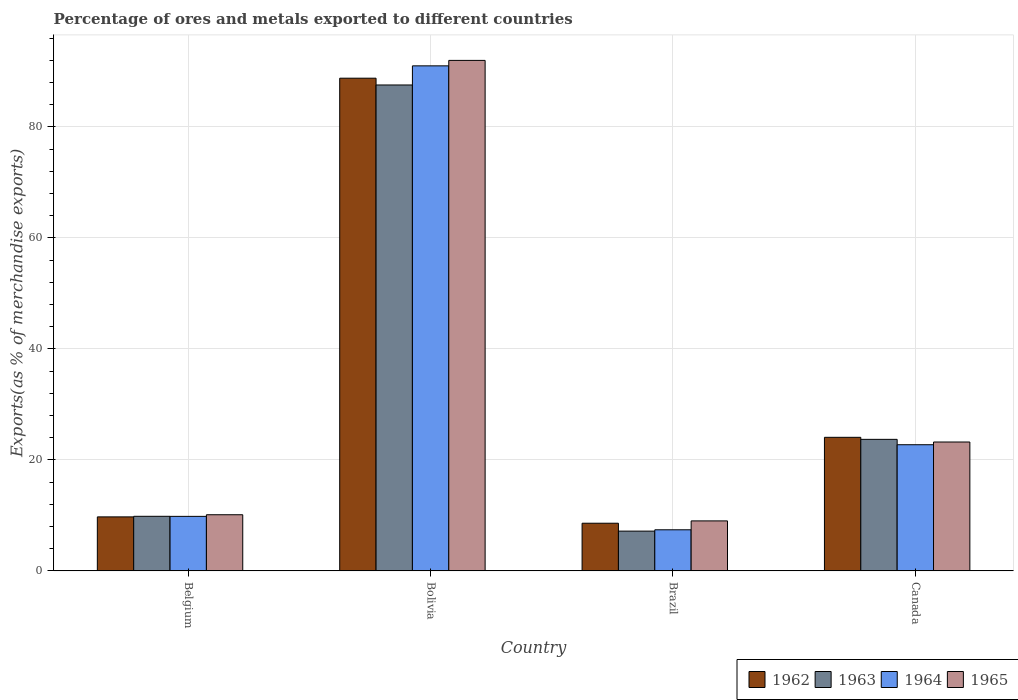Are the number of bars per tick equal to the number of legend labels?
Give a very brief answer. Yes. How many bars are there on the 3rd tick from the right?
Your response must be concise. 4. In how many cases, is the number of bars for a given country not equal to the number of legend labels?
Keep it short and to the point. 0. What is the percentage of exports to different countries in 1965 in Brazil?
Ensure brevity in your answer.  9.01. Across all countries, what is the maximum percentage of exports to different countries in 1965?
Offer a very short reply. 92. Across all countries, what is the minimum percentage of exports to different countries in 1964?
Your response must be concise. 7.41. In which country was the percentage of exports to different countries in 1962 maximum?
Provide a succinct answer. Bolivia. In which country was the percentage of exports to different countries in 1964 minimum?
Give a very brief answer. Brazil. What is the total percentage of exports to different countries in 1965 in the graph?
Make the answer very short. 134.36. What is the difference between the percentage of exports to different countries in 1964 in Belgium and that in Bolivia?
Offer a terse response. -81.19. What is the difference between the percentage of exports to different countries in 1964 in Belgium and the percentage of exports to different countries in 1963 in Brazil?
Keep it short and to the point. 2.66. What is the average percentage of exports to different countries in 1963 per country?
Offer a very short reply. 32.07. What is the difference between the percentage of exports to different countries of/in 1964 and percentage of exports to different countries of/in 1965 in Belgium?
Offer a terse response. -0.29. In how many countries, is the percentage of exports to different countries in 1965 greater than 4 %?
Offer a very short reply. 4. What is the ratio of the percentage of exports to different countries in 1964 in Belgium to that in Bolivia?
Keep it short and to the point. 0.11. Is the percentage of exports to different countries in 1962 in Belgium less than that in Bolivia?
Give a very brief answer. Yes. Is the difference between the percentage of exports to different countries in 1964 in Belgium and Bolivia greater than the difference between the percentage of exports to different countries in 1965 in Belgium and Bolivia?
Give a very brief answer. Yes. What is the difference between the highest and the second highest percentage of exports to different countries in 1962?
Give a very brief answer. 64.72. What is the difference between the highest and the lowest percentage of exports to different countries in 1964?
Ensure brevity in your answer.  83.61. In how many countries, is the percentage of exports to different countries in 1965 greater than the average percentage of exports to different countries in 1965 taken over all countries?
Give a very brief answer. 1. How many countries are there in the graph?
Give a very brief answer. 4. What is the difference between two consecutive major ticks on the Y-axis?
Offer a terse response. 20. Does the graph contain any zero values?
Offer a very short reply. No. Does the graph contain grids?
Give a very brief answer. Yes. Where does the legend appear in the graph?
Keep it short and to the point. Bottom right. How many legend labels are there?
Offer a very short reply. 4. What is the title of the graph?
Ensure brevity in your answer.  Percentage of ores and metals exported to different countries. What is the label or title of the Y-axis?
Provide a short and direct response. Exports(as % of merchandise exports). What is the Exports(as % of merchandise exports) in 1962 in Belgium?
Offer a terse response. 9.73. What is the Exports(as % of merchandise exports) in 1963 in Belgium?
Provide a succinct answer. 9.84. What is the Exports(as % of merchandise exports) of 1964 in Belgium?
Keep it short and to the point. 9.83. What is the Exports(as % of merchandise exports) of 1965 in Belgium?
Offer a very short reply. 10.12. What is the Exports(as % of merchandise exports) of 1962 in Bolivia?
Offer a very short reply. 88.79. What is the Exports(as % of merchandise exports) in 1963 in Bolivia?
Give a very brief answer. 87.57. What is the Exports(as % of merchandise exports) in 1964 in Bolivia?
Provide a succinct answer. 91.02. What is the Exports(as % of merchandise exports) in 1965 in Bolivia?
Offer a terse response. 92. What is the Exports(as % of merchandise exports) of 1962 in Brazil?
Make the answer very short. 8.59. What is the Exports(as % of merchandise exports) of 1963 in Brazil?
Keep it short and to the point. 7.17. What is the Exports(as % of merchandise exports) of 1964 in Brazil?
Provide a short and direct response. 7.41. What is the Exports(as % of merchandise exports) of 1965 in Brazil?
Offer a very short reply. 9.01. What is the Exports(as % of merchandise exports) in 1962 in Canada?
Keep it short and to the point. 24.07. What is the Exports(as % of merchandise exports) in 1963 in Canada?
Provide a succinct answer. 23.71. What is the Exports(as % of merchandise exports) in 1964 in Canada?
Keep it short and to the point. 22.74. What is the Exports(as % of merchandise exports) of 1965 in Canada?
Provide a succinct answer. 23.23. Across all countries, what is the maximum Exports(as % of merchandise exports) of 1962?
Your response must be concise. 88.79. Across all countries, what is the maximum Exports(as % of merchandise exports) of 1963?
Provide a short and direct response. 87.57. Across all countries, what is the maximum Exports(as % of merchandise exports) of 1964?
Your response must be concise. 91.02. Across all countries, what is the maximum Exports(as % of merchandise exports) in 1965?
Make the answer very short. 92. Across all countries, what is the minimum Exports(as % of merchandise exports) of 1962?
Your answer should be compact. 8.59. Across all countries, what is the minimum Exports(as % of merchandise exports) of 1963?
Keep it short and to the point. 7.17. Across all countries, what is the minimum Exports(as % of merchandise exports) in 1964?
Your response must be concise. 7.41. Across all countries, what is the minimum Exports(as % of merchandise exports) in 1965?
Give a very brief answer. 9.01. What is the total Exports(as % of merchandise exports) of 1962 in the graph?
Give a very brief answer. 131.19. What is the total Exports(as % of merchandise exports) of 1963 in the graph?
Your response must be concise. 128.28. What is the total Exports(as % of merchandise exports) in 1964 in the graph?
Offer a terse response. 130.99. What is the total Exports(as % of merchandise exports) in 1965 in the graph?
Your answer should be very brief. 134.36. What is the difference between the Exports(as % of merchandise exports) in 1962 in Belgium and that in Bolivia?
Your answer should be very brief. -79.06. What is the difference between the Exports(as % of merchandise exports) of 1963 in Belgium and that in Bolivia?
Ensure brevity in your answer.  -77.73. What is the difference between the Exports(as % of merchandise exports) of 1964 in Belgium and that in Bolivia?
Provide a short and direct response. -81.19. What is the difference between the Exports(as % of merchandise exports) of 1965 in Belgium and that in Bolivia?
Give a very brief answer. -81.88. What is the difference between the Exports(as % of merchandise exports) of 1962 in Belgium and that in Brazil?
Your answer should be very brief. 1.14. What is the difference between the Exports(as % of merchandise exports) in 1963 in Belgium and that in Brazil?
Your response must be concise. 2.67. What is the difference between the Exports(as % of merchandise exports) in 1964 in Belgium and that in Brazil?
Your answer should be very brief. 2.42. What is the difference between the Exports(as % of merchandise exports) in 1965 in Belgium and that in Brazil?
Offer a terse response. 1.11. What is the difference between the Exports(as % of merchandise exports) in 1962 in Belgium and that in Canada?
Your response must be concise. -14.34. What is the difference between the Exports(as % of merchandise exports) of 1963 in Belgium and that in Canada?
Your response must be concise. -13.87. What is the difference between the Exports(as % of merchandise exports) of 1964 in Belgium and that in Canada?
Keep it short and to the point. -12.91. What is the difference between the Exports(as % of merchandise exports) in 1965 in Belgium and that in Canada?
Provide a succinct answer. -13.11. What is the difference between the Exports(as % of merchandise exports) in 1962 in Bolivia and that in Brazil?
Offer a very short reply. 80.2. What is the difference between the Exports(as % of merchandise exports) of 1963 in Bolivia and that in Brazil?
Offer a terse response. 80.4. What is the difference between the Exports(as % of merchandise exports) of 1964 in Bolivia and that in Brazil?
Ensure brevity in your answer.  83.61. What is the difference between the Exports(as % of merchandise exports) of 1965 in Bolivia and that in Brazil?
Your answer should be very brief. 82.99. What is the difference between the Exports(as % of merchandise exports) of 1962 in Bolivia and that in Canada?
Make the answer very short. 64.72. What is the difference between the Exports(as % of merchandise exports) of 1963 in Bolivia and that in Canada?
Your answer should be very brief. 63.86. What is the difference between the Exports(as % of merchandise exports) in 1964 in Bolivia and that in Canada?
Offer a terse response. 68.28. What is the difference between the Exports(as % of merchandise exports) of 1965 in Bolivia and that in Canada?
Offer a very short reply. 68.77. What is the difference between the Exports(as % of merchandise exports) of 1962 in Brazil and that in Canada?
Provide a succinct answer. -15.48. What is the difference between the Exports(as % of merchandise exports) in 1963 in Brazil and that in Canada?
Provide a succinct answer. -16.54. What is the difference between the Exports(as % of merchandise exports) of 1964 in Brazil and that in Canada?
Provide a succinct answer. -15.33. What is the difference between the Exports(as % of merchandise exports) in 1965 in Brazil and that in Canada?
Your answer should be compact. -14.22. What is the difference between the Exports(as % of merchandise exports) of 1962 in Belgium and the Exports(as % of merchandise exports) of 1963 in Bolivia?
Your answer should be compact. -77.84. What is the difference between the Exports(as % of merchandise exports) of 1962 in Belgium and the Exports(as % of merchandise exports) of 1964 in Bolivia?
Your response must be concise. -81.28. What is the difference between the Exports(as % of merchandise exports) in 1962 in Belgium and the Exports(as % of merchandise exports) in 1965 in Bolivia?
Offer a terse response. -82.27. What is the difference between the Exports(as % of merchandise exports) of 1963 in Belgium and the Exports(as % of merchandise exports) of 1964 in Bolivia?
Offer a very short reply. -81.18. What is the difference between the Exports(as % of merchandise exports) in 1963 in Belgium and the Exports(as % of merchandise exports) in 1965 in Bolivia?
Offer a terse response. -82.16. What is the difference between the Exports(as % of merchandise exports) of 1964 in Belgium and the Exports(as % of merchandise exports) of 1965 in Bolivia?
Provide a succinct answer. -82.17. What is the difference between the Exports(as % of merchandise exports) in 1962 in Belgium and the Exports(as % of merchandise exports) in 1963 in Brazil?
Your answer should be very brief. 2.56. What is the difference between the Exports(as % of merchandise exports) of 1962 in Belgium and the Exports(as % of merchandise exports) of 1964 in Brazil?
Your answer should be very brief. 2.33. What is the difference between the Exports(as % of merchandise exports) in 1962 in Belgium and the Exports(as % of merchandise exports) in 1965 in Brazil?
Your answer should be compact. 0.72. What is the difference between the Exports(as % of merchandise exports) in 1963 in Belgium and the Exports(as % of merchandise exports) in 1964 in Brazil?
Give a very brief answer. 2.43. What is the difference between the Exports(as % of merchandise exports) of 1963 in Belgium and the Exports(as % of merchandise exports) of 1965 in Brazil?
Give a very brief answer. 0.83. What is the difference between the Exports(as % of merchandise exports) in 1964 in Belgium and the Exports(as % of merchandise exports) in 1965 in Brazil?
Ensure brevity in your answer.  0.82. What is the difference between the Exports(as % of merchandise exports) of 1962 in Belgium and the Exports(as % of merchandise exports) of 1963 in Canada?
Offer a very short reply. -13.97. What is the difference between the Exports(as % of merchandise exports) of 1962 in Belgium and the Exports(as % of merchandise exports) of 1964 in Canada?
Provide a short and direct response. -13. What is the difference between the Exports(as % of merchandise exports) in 1962 in Belgium and the Exports(as % of merchandise exports) in 1965 in Canada?
Give a very brief answer. -13.49. What is the difference between the Exports(as % of merchandise exports) of 1963 in Belgium and the Exports(as % of merchandise exports) of 1964 in Canada?
Give a very brief answer. -12.9. What is the difference between the Exports(as % of merchandise exports) of 1963 in Belgium and the Exports(as % of merchandise exports) of 1965 in Canada?
Give a very brief answer. -13.39. What is the difference between the Exports(as % of merchandise exports) of 1964 in Belgium and the Exports(as % of merchandise exports) of 1965 in Canada?
Your answer should be compact. -13.4. What is the difference between the Exports(as % of merchandise exports) of 1962 in Bolivia and the Exports(as % of merchandise exports) of 1963 in Brazil?
Offer a very short reply. 81.62. What is the difference between the Exports(as % of merchandise exports) in 1962 in Bolivia and the Exports(as % of merchandise exports) in 1964 in Brazil?
Ensure brevity in your answer.  81.39. What is the difference between the Exports(as % of merchandise exports) of 1962 in Bolivia and the Exports(as % of merchandise exports) of 1965 in Brazil?
Make the answer very short. 79.78. What is the difference between the Exports(as % of merchandise exports) of 1963 in Bolivia and the Exports(as % of merchandise exports) of 1964 in Brazil?
Give a very brief answer. 80.16. What is the difference between the Exports(as % of merchandise exports) in 1963 in Bolivia and the Exports(as % of merchandise exports) in 1965 in Brazil?
Your answer should be very brief. 78.56. What is the difference between the Exports(as % of merchandise exports) of 1964 in Bolivia and the Exports(as % of merchandise exports) of 1965 in Brazil?
Offer a very short reply. 82.01. What is the difference between the Exports(as % of merchandise exports) in 1962 in Bolivia and the Exports(as % of merchandise exports) in 1963 in Canada?
Your answer should be very brief. 65.09. What is the difference between the Exports(as % of merchandise exports) of 1962 in Bolivia and the Exports(as % of merchandise exports) of 1964 in Canada?
Your answer should be compact. 66.06. What is the difference between the Exports(as % of merchandise exports) in 1962 in Bolivia and the Exports(as % of merchandise exports) in 1965 in Canada?
Your answer should be compact. 65.57. What is the difference between the Exports(as % of merchandise exports) of 1963 in Bolivia and the Exports(as % of merchandise exports) of 1964 in Canada?
Make the answer very short. 64.83. What is the difference between the Exports(as % of merchandise exports) of 1963 in Bolivia and the Exports(as % of merchandise exports) of 1965 in Canada?
Offer a terse response. 64.34. What is the difference between the Exports(as % of merchandise exports) of 1964 in Bolivia and the Exports(as % of merchandise exports) of 1965 in Canada?
Give a very brief answer. 67.79. What is the difference between the Exports(as % of merchandise exports) of 1962 in Brazil and the Exports(as % of merchandise exports) of 1963 in Canada?
Offer a very short reply. -15.11. What is the difference between the Exports(as % of merchandise exports) of 1962 in Brazil and the Exports(as % of merchandise exports) of 1964 in Canada?
Make the answer very short. -14.15. What is the difference between the Exports(as % of merchandise exports) in 1962 in Brazil and the Exports(as % of merchandise exports) in 1965 in Canada?
Give a very brief answer. -14.64. What is the difference between the Exports(as % of merchandise exports) in 1963 in Brazil and the Exports(as % of merchandise exports) in 1964 in Canada?
Your answer should be very brief. -15.57. What is the difference between the Exports(as % of merchandise exports) of 1963 in Brazil and the Exports(as % of merchandise exports) of 1965 in Canada?
Provide a succinct answer. -16.06. What is the difference between the Exports(as % of merchandise exports) of 1964 in Brazil and the Exports(as % of merchandise exports) of 1965 in Canada?
Offer a very short reply. -15.82. What is the average Exports(as % of merchandise exports) of 1962 per country?
Give a very brief answer. 32.8. What is the average Exports(as % of merchandise exports) of 1963 per country?
Give a very brief answer. 32.07. What is the average Exports(as % of merchandise exports) of 1964 per country?
Provide a short and direct response. 32.75. What is the average Exports(as % of merchandise exports) of 1965 per country?
Make the answer very short. 33.59. What is the difference between the Exports(as % of merchandise exports) in 1962 and Exports(as % of merchandise exports) in 1963 in Belgium?
Make the answer very short. -0.1. What is the difference between the Exports(as % of merchandise exports) in 1962 and Exports(as % of merchandise exports) in 1964 in Belgium?
Your answer should be very brief. -0.09. What is the difference between the Exports(as % of merchandise exports) in 1962 and Exports(as % of merchandise exports) in 1965 in Belgium?
Provide a succinct answer. -0.39. What is the difference between the Exports(as % of merchandise exports) of 1963 and Exports(as % of merchandise exports) of 1964 in Belgium?
Make the answer very short. 0.01. What is the difference between the Exports(as % of merchandise exports) of 1963 and Exports(as % of merchandise exports) of 1965 in Belgium?
Your answer should be compact. -0.28. What is the difference between the Exports(as % of merchandise exports) in 1964 and Exports(as % of merchandise exports) in 1965 in Belgium?
Give a very brief answer. -0.29. What is the difference between the Exports(as % of merchandise exports) in 1962 and Exports(as % of merchandise exports) in 1963 in Bolivia?
Provide a succinct answer. 1.22. What is the difference between the Exports(as % of merchandise exports) in 1962 and Exports(as % of merchandise exports) in 1964 in Bolivia?
Offer a terse response. -2.22. What is the difference between the Exports(as % of merchandise exports) of 1962 and Exports(as % of merchandise exports) of 1965 in Bolivia?
Offer a terse response. -3.21. What is the difference between the Exports(as % of merchandise exports) of 1963 and Exports(as % of merchandise exports) of 1964 in Bolivia?
Your response must be concise. -3.45. What is the difference between the Exports(as % of merchandise exports) in 1963 and Exports(as % of merchandise exports) in 1965 in Bolivia?
Provide a short and direct response. -4.43. What is the difference between the Exports(as % of merchandise exports) of 1964 and Exports(as % of merchandise exports) of 1965 in Bolivia?
Your answer should be compact. -0.98. What is the difference between the Exports(as % of merchandise exports) of 1962 and Exports(as % of merchandise exports) of 1963 in Brazil?
Provide a short and direct response. 1.42. What is the difference between the Exports(as % of merchandise exports) in 1962 and Exports(as % of merchandise exports) in 1964 in Brazil?
Provide a short and direct response. 1.18. What is the difference between the Exports(as % of merchandise exports) of 1962 and Exports(as % of merchandise exports) of 1965 in Brazil?
Your response must be concise. -0.42. What is the difference between the Exports(as % of merchandise exports) of 1963 and Exports(as % of merchandise exports) of 1964 in Brazil?
Provide a succinct answer. -0.24. What is the difference between the Exports(as % of merchandise exports) in 1963 and Exports(as % of merchandise exports) in 1965 in Brazil?
Keep it short and to the point. -1.84. What is the difference between the Exports(as % of merchandise exports) in 1964 and Exports(as % of merchandise exports) in 1965 in Brazil?
Keep it short and to the point. -1.6. What is the difference between the Exports(as % of merchandise exports) of 1962 and Exports(as % of merchandise exports) of 1963 in Canada?
Offer a very short reply. 0.37. What is the difference between the Exports(as % of merchandise exports) of 1962 and Exports(as % of merchandise exports) of 1964 in Canada?
Give a very brief answer. 1.33. What is the difference between the Exports(as % of merchandise exports) in 1962 and Exports(as % of merchandise exports) in 1965 in Canada?
Offer a terse response. 0.84. What is the difference between the Exports(as % of merchandise exports) of 1963 and Exports(as % of merchandise exports) of 1964 in Canada?
Keep it short and to the point. 0.97. What is the difference between the Exports(as % of merchandise exports) in 1963 and Exports(as % of merchandise exports) in 1965 in Canada?
Offer a terse response. 0.48. What is the difference between the Exports(as % of merchandise exports) in 1964 and Exports(as % of merchandise exports) in 1965 in Canada?
Your answer should be very brief. -0.49. What is the ratio of the Exports(as % of merchandise exports) of 1962 in Belgium to that in Bolivia?
Keep it short and to the point. 0.11. What is the ratio of the Exports(as % of merchandise exports) of 1963 in Belgium to that in Bolivia?
Keep it short and to the point. 0.11. What is the ratio of the Exports(as % of merchandise exports) of 1964 in Belgium to that in Bolivia?
Your response must be concise. 0.11. What is the ratio of the Exports(as % of merchandise exports) of 1965 in Belgium to that in Bolivia?
Your response must be concise. 0.11. What is the ratio of the Exports(as % of merchandise exports) in 1962 in Belgium to that in Brazil?
Provide a succinct answer. 1.13. What is the ratio of the Exports(as % of merchandise exports) of 1963 in Belgium to that in Brazil?
Your answer should be very brief. 1.37. What is the ratio of the Exports(as % of merchandise exports) of 1964 in Belgium to that in Brazil?
Make the answer very short. 1.33. What is the ratio of the Exports(as % of merchandise exports) of 1965 in Belgium to that in Brazil?
Offer a very short reply. 1.12. What is the ratio of the Exports(as % of merchandise exports) in 1962 in Belgium to that in Canada?
Keep it short and to the point. 0.4. What is the ratio of the Exports(as % of merchandise exports) of 1963 in Belgium to that in Canada?
Your response must be concise. 0.41. What is the ratio of the Exports(as % of merchandise exports) of 1964 in Belgium to that in Canada?
Offer a very short reply. 0.43. What is the ratio of the Exports(as % of merchandise exports) in 1965 in Belgium to that in Canada?
Your answer should be very brief. 0.44. What is the ratio of the Exports(as % of merchandise exports) in 1962 in Bolivia to that in Brazil?
Keep it short and to the point. 10.33. What is the ratio of the Exports(as % of merchandise exports) of 1963 in Bolivia to that in Brazil?
Provide a short and direct response. 12.21. What is the ratio of the Exports(as % of merchandise exports) in 1964 in Bolivia to that in Brazil?
Your answer should be compact. 12.29. What is the ratio of the Exports(as % of merchandise exports) in 1965 in Bolivia to that in Brazil?
Give a very brief answer. 10.21. What is the ratio of the Exports(as % of merchandise exports) of 1962 in Bolivia to that in Canada?
Your answer should be very brief. 3.69. What is the ratio of the Exports(as % of merchandise exports) of 1963 in Bolivia to that in Canada?
Your answer should be compact. 3.69. What is the ratio of the Exports(as % of merchandise exports) in 1964 in Bolivia to that in Canada?
Offer a very short reply. 4. What is the ratio of the Exports(as % of merchandise exports) of 1965 in Bolivia to that in Canada?
Ensure brevity in your answer.  3.96. What is the ratio of the Exports(as % of merchandise exports) in 1962 in Brazil to that in Canada?
Make the answer very short. 0.36. What is the ratio of the Exports(as % of merchandise exports) in 1963 in Brazil to that in Canada?
Ensure brevity in your answer.  0.3. What is the ratio of the Exports(as % of merchandise exports) in 1964 in Brazil to that in Canada?
Your response must be concise. 0.33. What is the ratio of the Exports(as % of merchandise exports) of 1965 in Brazil to that in Canada?
Your answer should be very brief. 0.39. What is the difference between the highest and the second highest Exports(as % of merchandise exports) in 1962?
Your answer should be very brief. 64.72. What is the difference between the highest and the second highest Exports(as % of merchandise exports) in 1963?
Your answer should be compact. 63.86. What is the difference between the highest and the second highest Exports(as % of merchandise exports) in 1964?
Your response must be concise. 68.28. What is the difference between the highest and the second highest Exports(as % of merchandise exports) of 1965?
Your answer should be very brief. 68.77. What is the difference between the highest and the lowest Exports(as % of merchandise exports) of 1962?
Your answer should be very brief. 80.2. What is the difference between the highest and the lowest Exports(as % of merchandise exports) in 1963?
Provide a succinct answer. 80.4. What is the difference between the highest and the lowest Exports(as % of merchandise exports) in 1964?
Ensure brevity in your answer.  83.61. What is the difference between the highest and the lowest Exports(as % of merchandise exports) of 1965?
Make the answer very short. 82.99. 